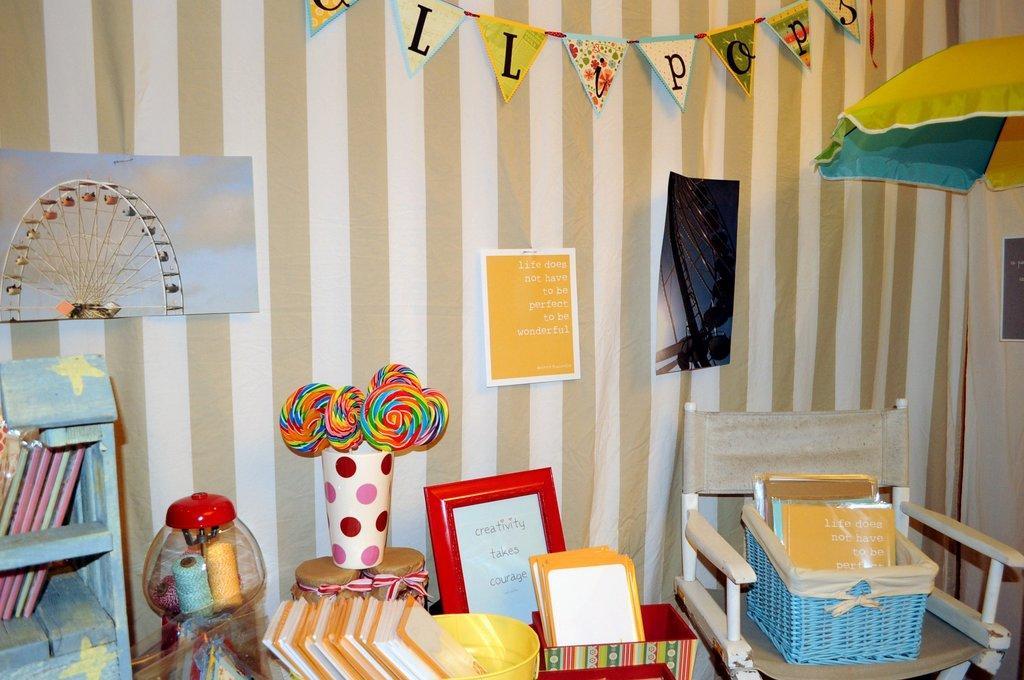How would you summarize this image in a sentence or two? In this image there is book shelf, a poster on the wall in the left corner. There is a poster on the wall and umbrella in the right corner. There is a chair with an object on it, candies and some objects on the table in the foreground. And there is a wall with some posters on it in the background. 